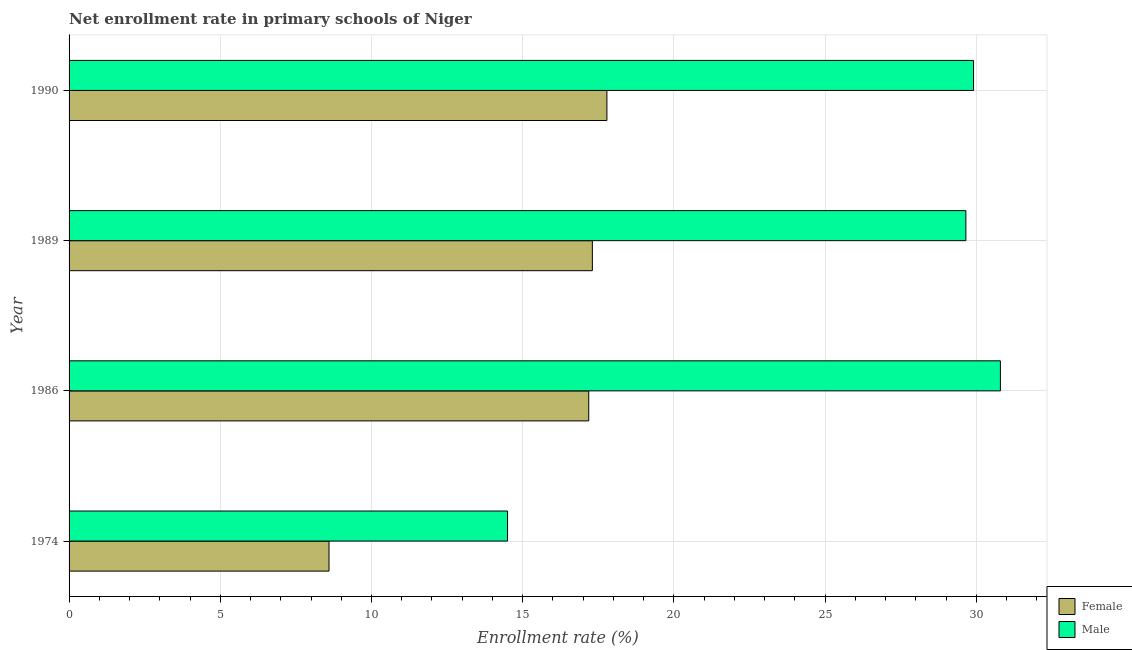How many different coloured bars are there?
Give a very brief answer. 2. How many bars are there on the 4th tick from the top?
Make the answer very short. 2. How many bars are there on the 4th tick from the bottom?
Keep it short and to the point. 2. What is the enrollment rate of female students in 1990?
Keep it short and to the point. 17.78. Across all years, what is the maximum enrollment rate of male students?
Your answer should be very brief. 30.8. Across all years, what is the minimum enrollment rate of male students?
Offer a terse response. 14.5. In which year was the enrollment rate of female students minimum?
Your answer should be very brief. 1974. What is the total enrollment rate of male students in the graph?
Offer a very short reply. 104.86. What is the difference between the enrollment rate of female students in 1974 and that in 1986?
Give a very brief answer. -8.59. What is the difference between the enrollment rate of female students in 1989 and the enrollment rate of male students in 1986?
Your answer should be very brief. -13.49. What is the average enrollment rate of male students per year?
Provide a succinct answer. 26.21. In the year 1986, what is the difference between the enrollment rate of male students and enrollment rate of female students?
Your answer should be very brief. 13.61. In how many years, is the enrollment rate of female students greater than 19 %?
Offer a terse response. 0. Is the enrollment rate of female students in 1974 less than that in 1989?
Your answer should be very brief. Yes. What is the difference between the highest and the second highest enrollment rate of female students?
Keep it short and to the point. 0.48. What is the difference between the highest and the lowest enrollment rate of female students?
Ensure brevity in your answer.  9.19. What does the 1st bar from the bottom in 1990 represents?
Keep it short and to the point. Female. How many bars are there?
Your response must be concise. 8. Does the graph contain grids?
Give a very brief answer. Yes. Where does the legend appear in the graph?
Keep it short and to the point. Bottom right. How many legend labels are there?
Offer a terse response. 2. How are the legend labels stacked?
Provide a succinct answer. Vertical. What is the title of the graph?
Keep it short and to the point. Net enrollment rate in primary schools of Niger. Does "Unregistered firms" appear as one of the legend labels in the graph?
Provide a succinct answer. No. What is the label or title of the X-axis?
Offer a terse response. Enrollment rate (%). What is the label or title of the Y-axis?
Your response must be concise. Year. What is the Enrollment rate (%) in Female in 1974?
Keep it short and to the point. 8.6. What is the Enrollment rate (%) in Male in 1974?
Your answer should be very brief. 14.5. What is the Enrollment rate (%) in Female in 1986?
Your answer should be compact. 17.18. What is the Enrollment rate (%) in Male in 1986?
Keep it short and to the point. 30.8. What is the Enrollment rate (%) of Female in 1989?
Ensure brevity in your answer.  17.3. What is the Enrollment rate (%) of Male in 1989?
Provide a succinct answer. 29.65. What is the Enrollment rate (%) of Female in 1990?
Make the answer very short. 17.78. What is the Enrollment rate (%) of Male in 1990?
Your answer should be very brief. 29.91. Across all years, what is the maximum Enrollment rate (%) in Female?
Offer a terse response. 17.78. Across all years, what is the maximum Enrollment rate (%) in Male?
Offer a terse response. 30.8. Across all years, what is the minimum Enrollment rate (%) in Female?
Your answer should be very brief. 8.6. Across all years, what is the minimum Enrollment rate (%) in Male?
Ensure brevity in your answer.  14.5. What is the total Enrollment rate (%) in Female in the graph?
Give a very brief answer. 60.87. What is the total Enrollment rate (%) of Male in the graph?
Your response must be concise. 104.86. What is the difference between the Enrollment rate (%) in Female in 1974 and that in 1986?
Your answer should be compact. -8.59. What is the difference between the Enrollment rate (%) in Male in 1974 and that in 1986?
Offer a terse response. -16.3. What is the difference between the Enrollment rate (%) in Female in 1974 and that in 1989?
Your response must be concise. -8.71. What is the difference between the Enrollment rate (%) in Male in 1974 and that in 1989?
Your response must be concise. -15.16. What is the difference between the Enrollment rate (%) in Female in 1974 and that in 1990?
Offer a very short reply. -9.19. What is the difference between the Enrollment rate (%) in Male in 1974 and that in 1990?
Offer a terse response. -15.41. What is the difference between the Enrollment rate (%) in Female in 1986 and that in 1989?
Your answer should be very brief. -0.12. What is the difference between the Enrollment rate (%) of Male in 1986 and that in 1989?
Your response must be concise. 1.14. What is the difference between the Enrollment rate (%) in Female in 1986 and that in 1990?
Give a very brief answer. -0.6. What is the difference between the Enrollment rate (%) of Male in 1986 and that in 1990?
Provide a short and direct response. 0.89. What is the difference between the Enrollment rate (%) in Female in 1989 and that in 1990?
Your response must be concise. -0.48. What is the difference between the Enrollment rate (%) in Male in 1989 and that in 1990?
Offer a very short reply. -0.25. What is the difference between the Enrollment rate (%) in Female in 1974 and the Enrollment rate (%) in Male in 1986?
Give a very brief answer. -22.2. What is the difference between the Enrollment rate (%) in Female in 1974 and the Enrollment rate (%) in Male in 1989?
Offer a terse response. -21.06. What is the difference between the Enrollment rate (%) of Female in 1974 and the Enrollment rate (%) of Male in 1990?
Ensure brevity in your answer.  -21.31. What is the difference between the Enrollment rate (%) of Female in 1986 and the Enrollment rate (%) of Male in 1989?
Provide a short and direct response. -12.47. What is the difference between the Enrollment rate (%) in Female in 1986 and the Enrollment rate (%) in Male in 1990?
Make the answer very short. -12.72. What is the difference between the Enrollment rate (%) of Female in 1989 and the Enrollment rate (%) of Male in 1990?
Offer a very short reply. -12.6. What is the average Enrollment rate (%) of Female per year?
Your answer should be compact. 15.22. What is the average Enrollment rate (%) of Male per year?
Offer a terse response. 26.21. In the year 1974, what is the difference between the Enrollment rate (%) of Female and Enrollment rate (%) of Male?
Provide a succinct answer. -5.9. In the year 1986, what is the difference between the Enrollment rate (%) in Female and Enrollment rate (%) in Male?
Keep it short and to the point. -13.61. In the year 1989, what is the difference between the Enrollment rate (%) of Female and Enrollment rate (%) of Male?
Keep it short and to the point. -12.35. In the year 1990, what is the difference between the Enrollment rate (%) of Female and Enrollment rate (%) of Male?
Offer a terse response. -12.12. What is the ratio of the Enrollment rate (%) of Female in 1974 to that in 1986?
Make the answer very short. 0.5. What is the ratio of the Enrollment rate (%) in Male in 1974 to that in 1986?
Your answer should be very brief. 0.47. What is the ratio of the Enrollment rate (%) in Female in 1974 to that in 1989?
Your answer should be very brief. 0.5. What is the ratio of the Enrollment rate (%) of Male in 1974 to that in 1989?
Provide a short and direct response. 0.49. What is the ratio of the Enrollment rate (%) in Female in 1974 to that in 1990?
Your answer should be compact. 0.48. What is the ratio of the Enrollment rate (%) in Male in 1974 to that in 1990?
Offer a terse response. 0.48. What is the ratio of the Enrollment rate (%) of Female in 1986 to that in 1989?
Ensure brevity in your answer.  0.99. What is the ratio of the Enrollment rate (%) in Male in 1986 to that in 1989?
Offer a very short reply. 1.04. What is the ratio of the Enrollment rate (%) in Female in 1986 to that in 1990?
Your answer should be compact. 0.97. What is the ratio of the Enrollment rate (%) of Male in 1986 to that in 1990?
Ensure brevity in your answer.  1.03. What is the difference between the highest and the second highest Enrollment rate (%) in Female?
Ensure brevity in your answer.  0.48. What is the difference between the highest and the second highest Enrollment rate (%) of Male?
Ensure brevity in your answer.  0.89. What is the difference between the highest and the lowest Enrollment rate (%) in Female?
Offer a very short reply. 9.19. What is the difference between the highest and the lowest Enrollment rate (%) in Male?
Ensure brevity in your answer.  16.3. 